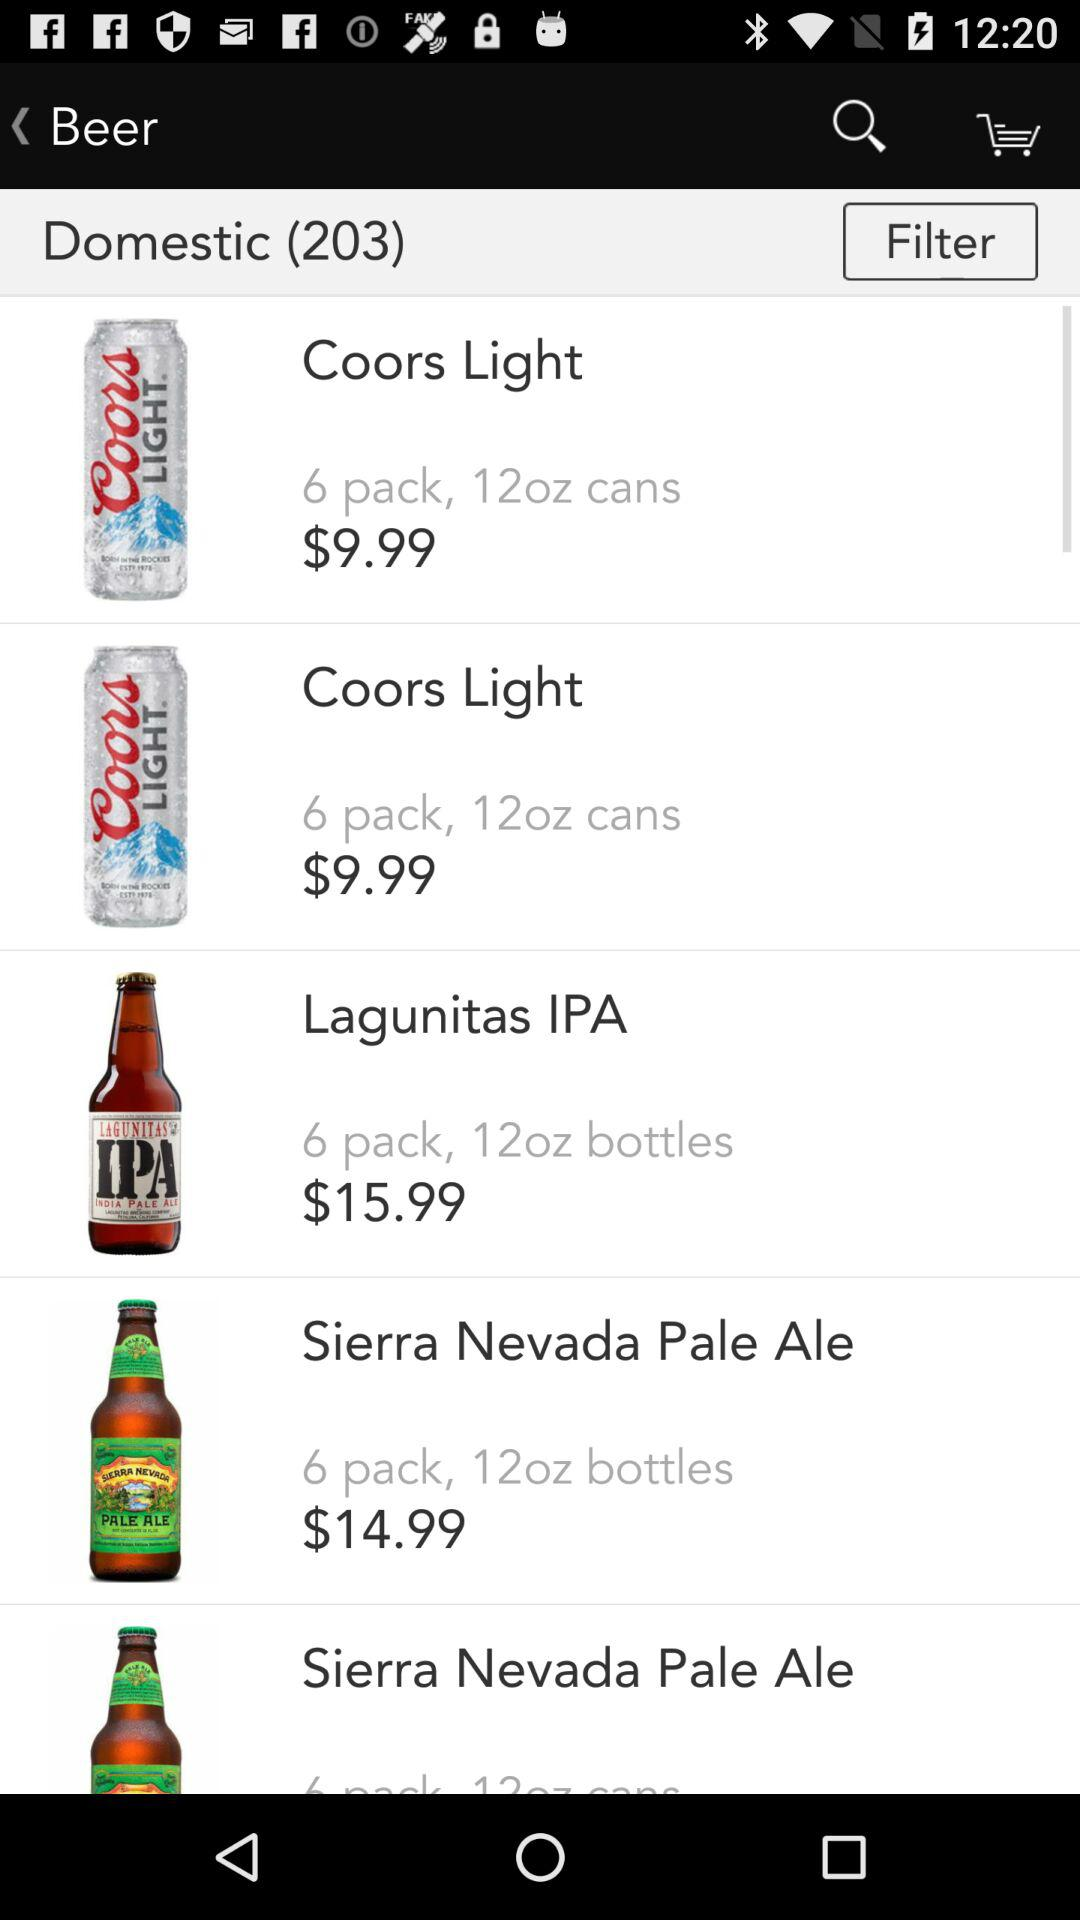How much more does Sierra Nevada Pale Ale cost than Coors Light?
Answer the question using a single word or phrase. $5.00 